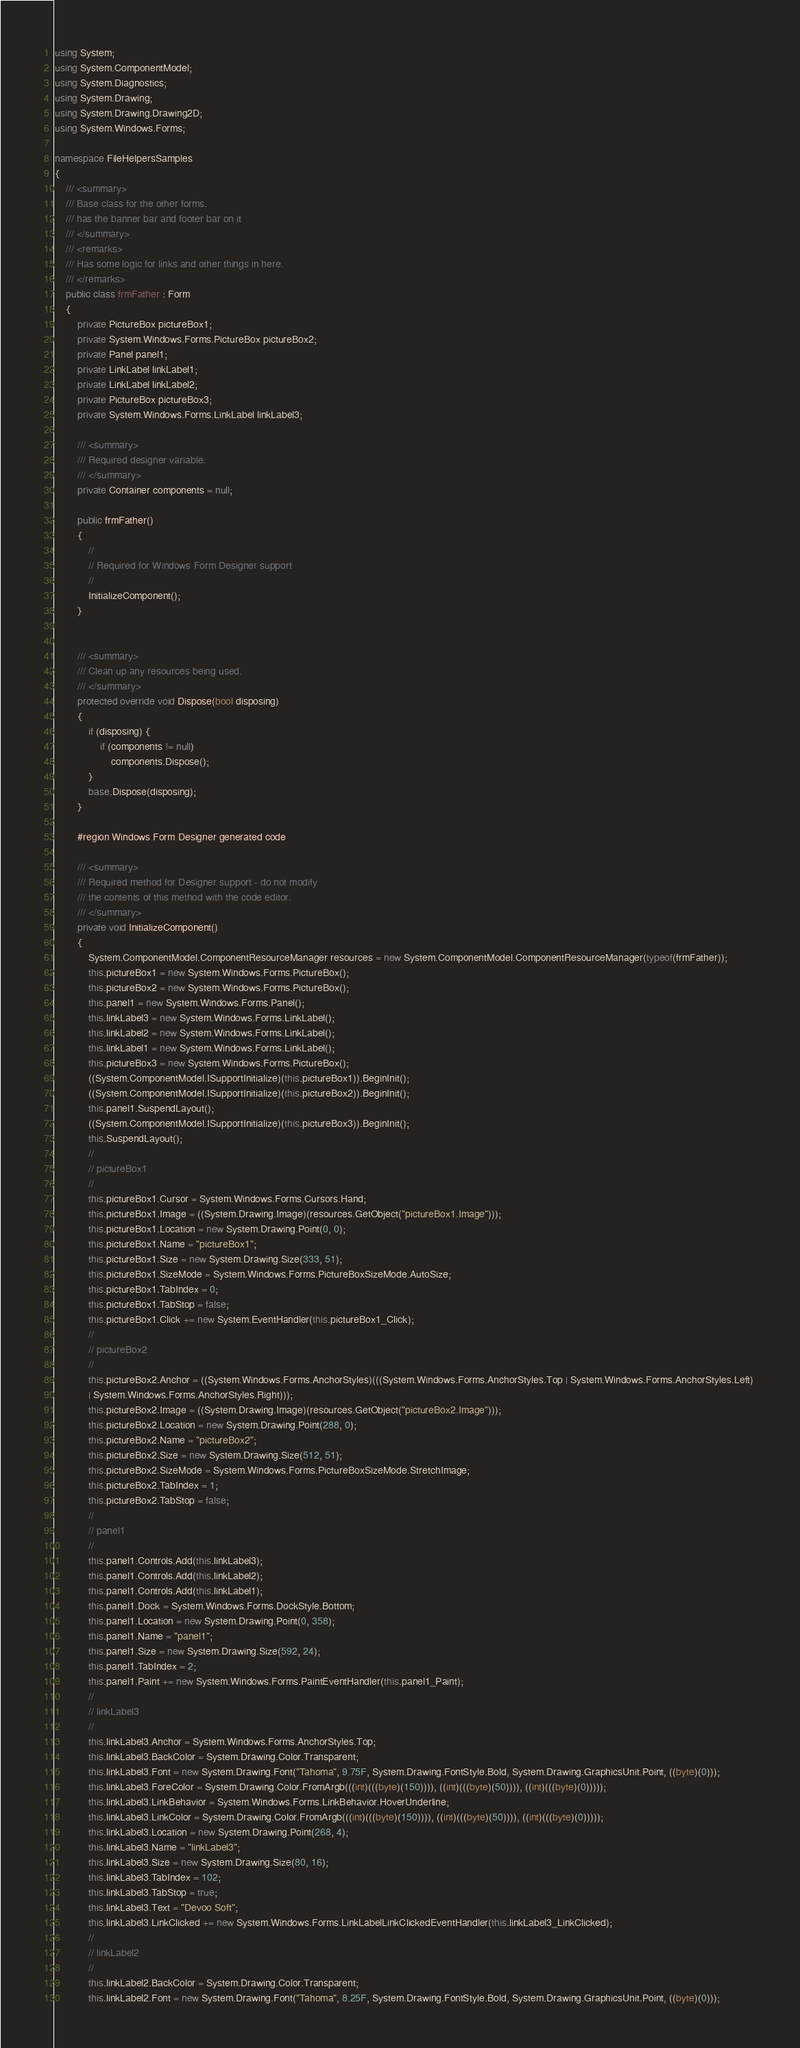Convert code to text. <code><loc_0><loc_0><loc_500><loc_500><_C#_>using System;
using System.ComponentModel;
using System.Diagnostics;
using System.Drawing;
using System.Drawing.Drawing2D;
using System.Windows.Forms;

namespace FileHelpersSamples
{
    /// <summary>
    /// Base class for the other forms.
    /// has the banner bar and footer bar on it
    /// </summary>
    /// <remarks>
    /// Has some logic for links and other things in here.
    /// </remarks>
    public class frmFather : Form
    {
        private PictureBox pictureBox1;
        private System.Windows.Forms.PictureBox pictureBox2;
        private Panel panel1;
        private LinkLabel linkLabel1;
        private LinkLabel linkLabel2;
        private PictureBox pictureBox3;
        private System.Windows.Forms.LinkLabel linkLabel3;

        /// <summary>
        /// Required designer variable.
        /// </summary>
        private Container components = null;

        public frmFather()
        {
            //
            // Required for Windows Form Designer support
            //
            InitializeComponent();
        }


        /// <summary>
        /// Clean up any resources being used.
        /// </summary>
        protected override void Dispose(bool disposing)
        {
            if (disposing) {
                if (components != null)
                    components.Dispose();
            }
            base.Dispose(disposing);
        }

        #region Windows Form Designer generated code

        /// <summary>
        /// Required method for Designer support - do not modify
        /// the contents of this method with the code editor.
        /// </summary>
        private void InitializeComponent()
        {
            System.ComponentModel.ComponentResourceManager resources = new System.ComponentModel.ComponentResourceManager(typeof(frmFather));
            this.pictureBox1 = new System.Windows.Forms.PictureBox();
            this.pictureBox2 = new System.Windows.Forms.PictureBox();
            this.panel1 = new System.Windows.Forms.Panel();
            this.linkLabel3 = new System.Windows.Forms.LinkLabel();
            this.linkLabel2 = new System.Windows.Forms.LinkLabel();
            this.linkLabel1 = new System.Windows.Forms.LinkLabel();
            this.pictureBox3 = new System.Windows.Forms.PictureBox();
            ((System.ComponentModel.ISupportInitialize)(this.pictureBox1)).BeginInit();
            ((System.ComponentModel.ISupportInitialize)(this.pictureBox2)).BeginInit();
            this.panel1.SuspendLayout();
            ((System.ComponentModel.ISupportInitialize)(this.pictureBox3)).BeginInit();
            this.SuspendLayout();
            // 
            // pictureBox1
            // 
            this.pictureBox1.Cursor = System.Windows.Forms.Cursors.Hand;
            this.pictureBox1.Image = ((System.Drawing.Image)(resources.GetObject("pictureBox1.Image")));
            this.pictureBox1.Location = new System.Drawing.Point(0, 0);
            this.pictureBox1.Name = "pictureBox1";
            this.pictureBox1.Size = new System.Drawing.Size(333, 51);
            this.pictureBox1.SizeMode = System.Windows.Forms.PictureBoxSizeMode.AutoSize;
            this.pictureBox1.TabIndex = 0;
            this.pictureBox1.TabStop = false;
            this.pictureBox1.Click += new System.EventHandler(this.pictureBox1_Click);
            // 
            // pictureBox2
            // 
            this.pictureBox2.Anchor = ((System.Windows.Forms.AnchorStyles)(((System.Windows.Forms.AnchorStyles.Top | System.Windows.Forms.AnchorStyles.Left) 
            | System.Windows.Forms.AnchorStyles.Right)));
            this.pictureBox2.Image = ((System.Drawing.Image)(resources.GetObject("pictureBox2.Image")));
            this.pictureBox2.Location = new System.Drawing.Point(288, 0);
            this.pictureBox2.Name = "pictureBox2";
            this.pictureBox2.Size = new System.Drawing.Size(512, 51);
            this.pictureBox2.SizeMode = System.Windows.Forms.PictureBoxSizeMode.StretchImage;
            this.pictureBox2.TabIndex = 1;
            this.pictureBox2.TabStop = false;
            // 
            // panel1
            // 
            this.panel1.Controls.Add(this.linkLabel3);
            this.panel1.Controls.Add(this.linkLabel2);
            this.panel1.Controls.Add(this.linkLabel1);
            this.panel1.Dock = System.Windows.Forms.DockStyle.Bottom;
            this.panel1.Location = new System.Drawing.Point(0, 358);
            this.panel1.Name = "panel1";
            this.panel1.Size = new System.Drawing.Size(592, 24);
            this.panel1.TabIndex = 2;
            this.panel1.Paint += new System.Windows.Forms.PaintEventHandler(this.panel1_Paint);
            // 
            // linkLabel3
            // 
            this.linkLabel3.Anchor = System.Windows.Forms.AnchorStyles.Top;
            this.linkLabel3.BackColor = System.Drawing.Color.Transparent;
            this.linkLabel3.Font = new System.Drawing.Font("Tahoma", 9.75F, System.Drawing.FontStyle.Bold, System.Drawing.GraphicsUnit.Point, ((byte)(0)));
            this.linkLabel3.ForeColor = System.Drawing.Color.FromArgb(((int)(((byte)(150)))), ((int)(((byte)(50)))), ((int)(((byte)(0)))));
            this.linkLabel3.LinkBehavior = System.Windows.Forms.LinkBehavior.HoverUnderline;
            this.linkLabel3.LinkColor = System.Drawing.Color.FromArgb(((int)(((byte)(150)))), ((int)(((byte)(50)))), ((int)(((byte)(0)))));
            this.linkLabel3.Location = new System.Drawing.Point(268, 4);
            this.linkLabel3.Name = "linkLabel3";
            this.linkLabel3.Size = new System.Drawing.Size(80, 16);
            this.linkLabel3.TabIndex = 102;
            this.linkLabel3.TabStop = true;
            this.linkLabel3.Text = "Devoo Soft";
            this.linkLabel3.LinkClicked += new System.Windows.Forms.LinkLabelLinkClickedEventHandler(this.linkLabel3_LinkClicked);
            // 
            // linkLabel2
            // 
            this.linkLabel2.BackColor = System.Drawing.Color.Transparent;
            this.linkLabel2.Font = new System.Drawing.Font("Tahoma", 8.25F, System.Drawing.FontStyle.Bold, System.Drawing.GraphicsUnit.Point, ((byte)(0)));</code> 